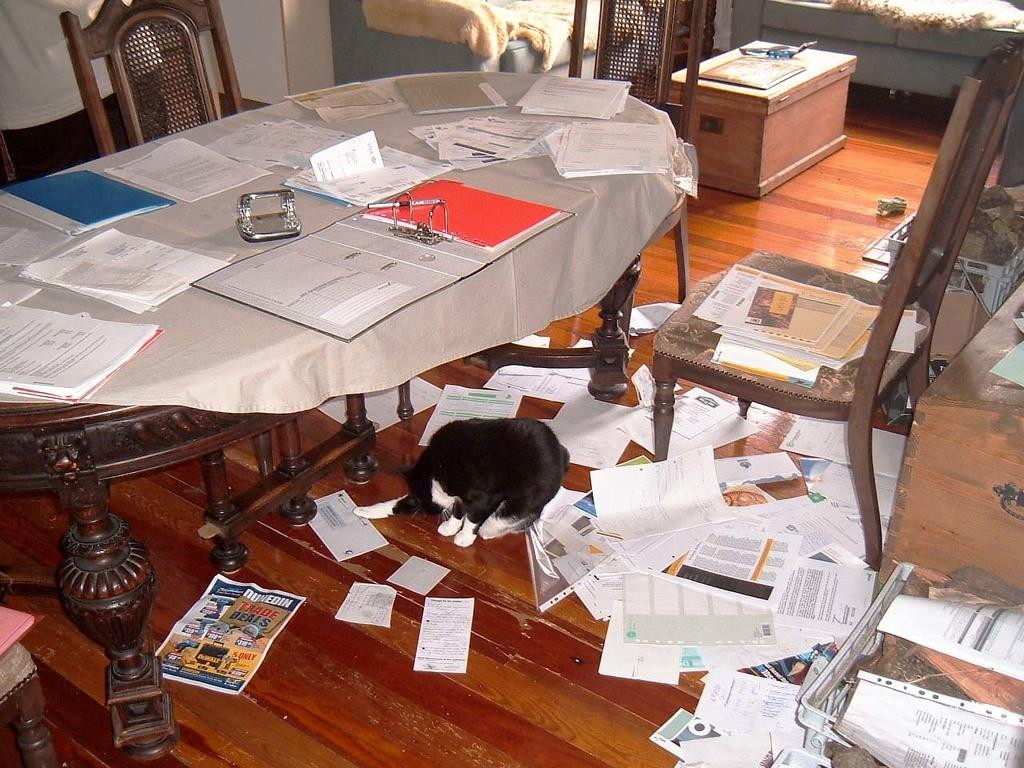What type of furniture is in the image? There is a table in the image. What items can be seen on the table? Files, papers, books, and a table sheet are on the table. Is there any other furniture visible in the image? Yes, there are three chairs in the image. What is the cat's location in the image? The cat is below the table. Are there any papers on the floor in the image? Yes, papers are scattered on the floor. How does the hole in the table affect the organization of the files? There is no hole in the table mentioned in the image, so it cannot affect the organization of the files. 